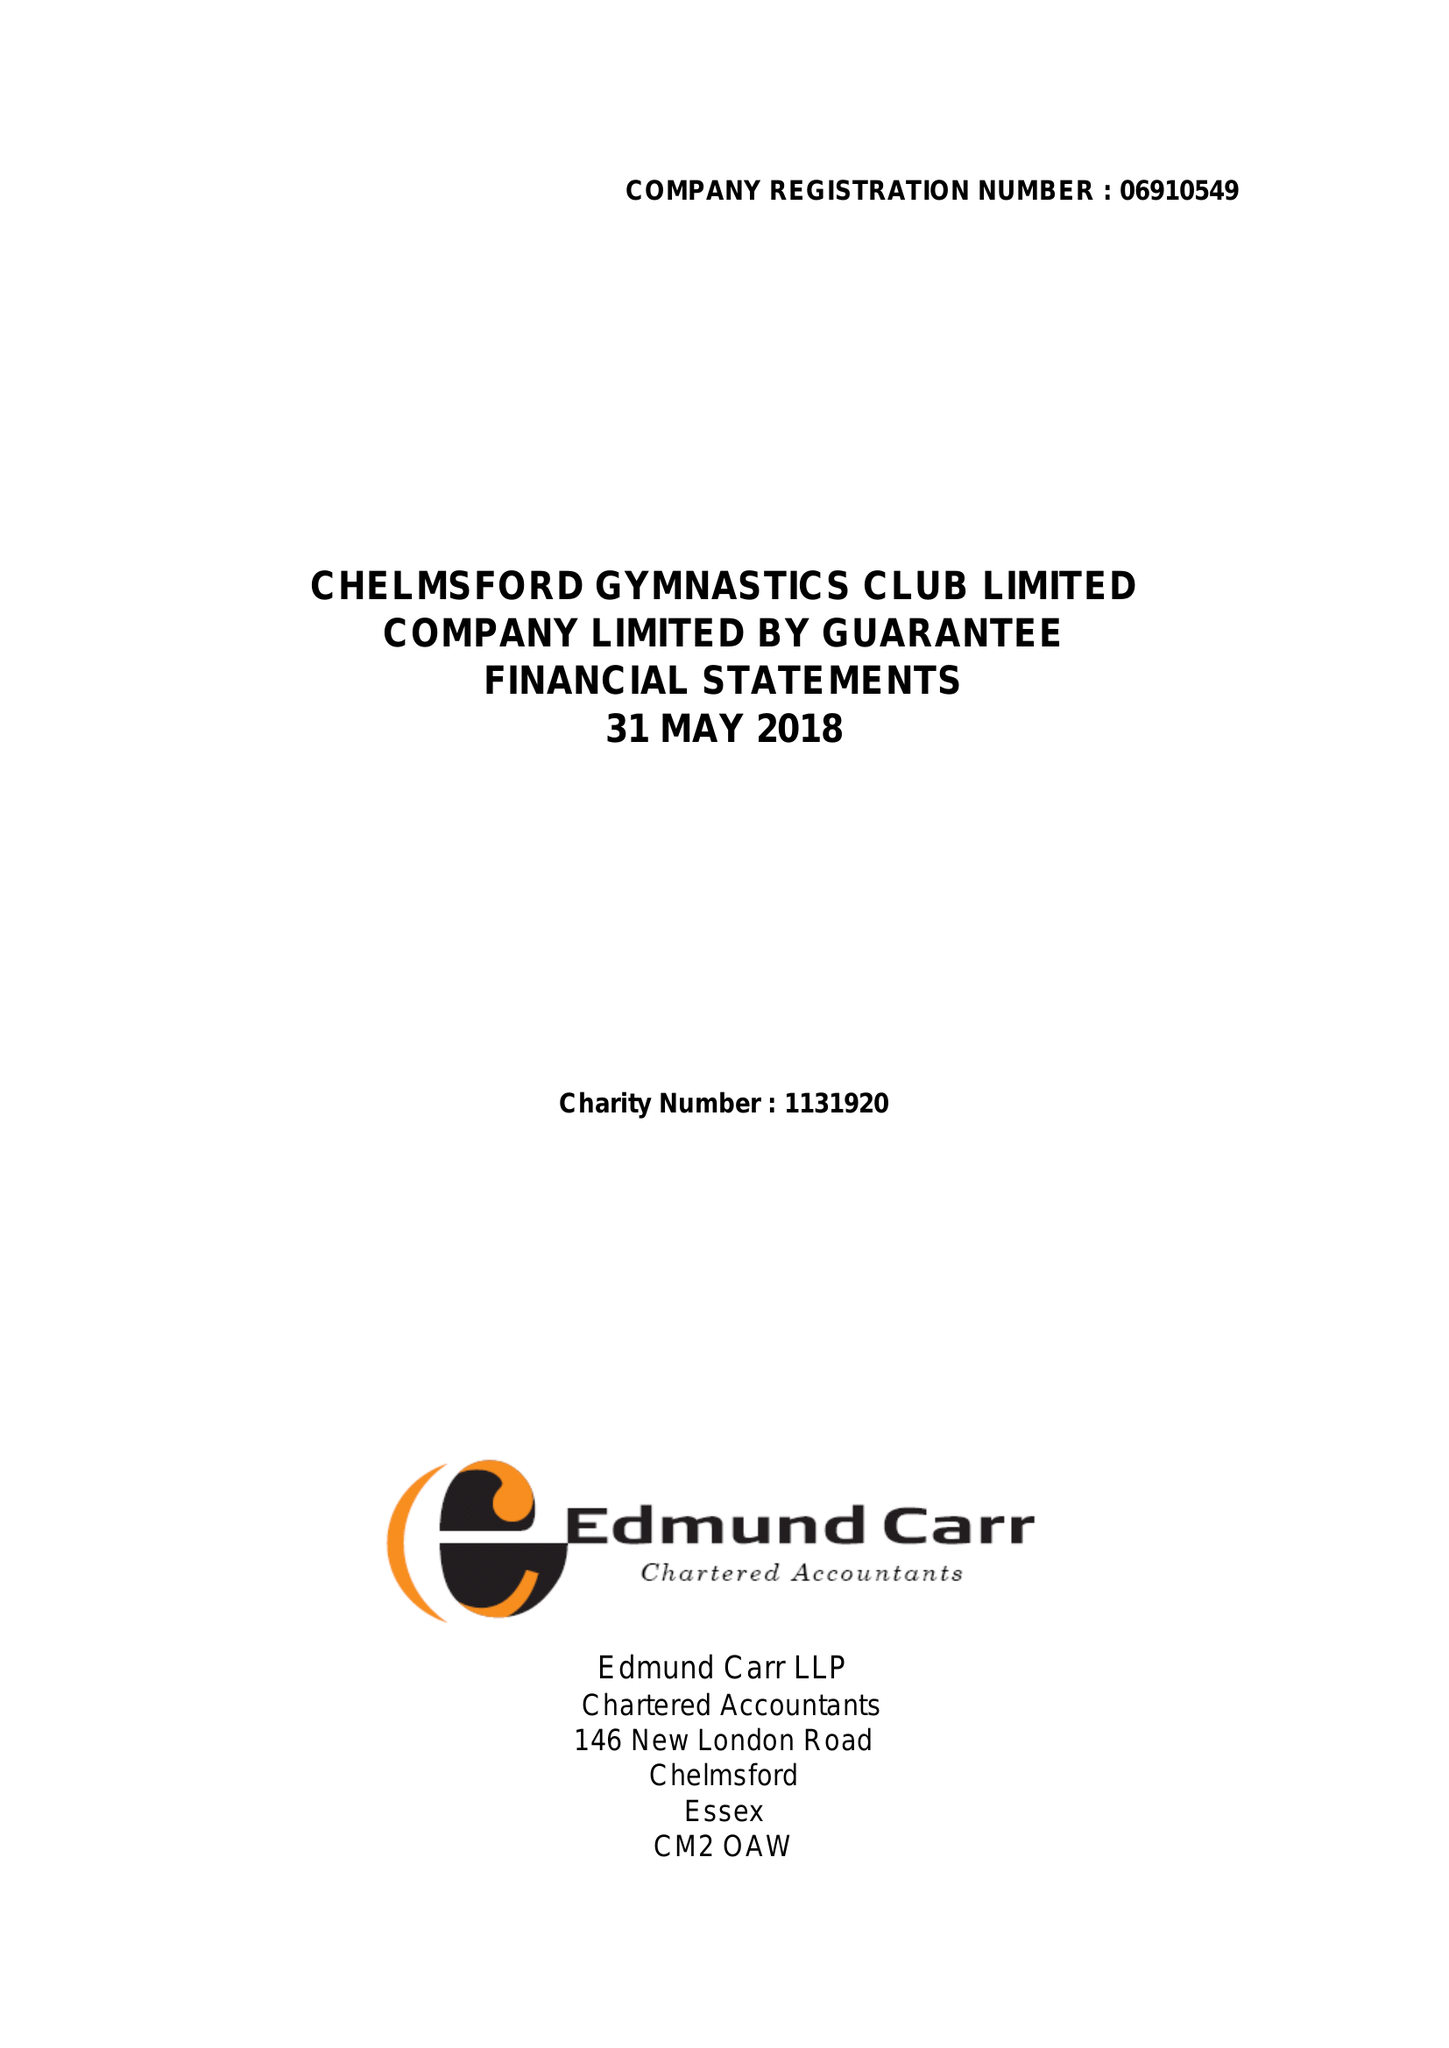What is the value for the income_annually_in_british_pounds?
Answer the question using a single word or phrase. 413994.00 